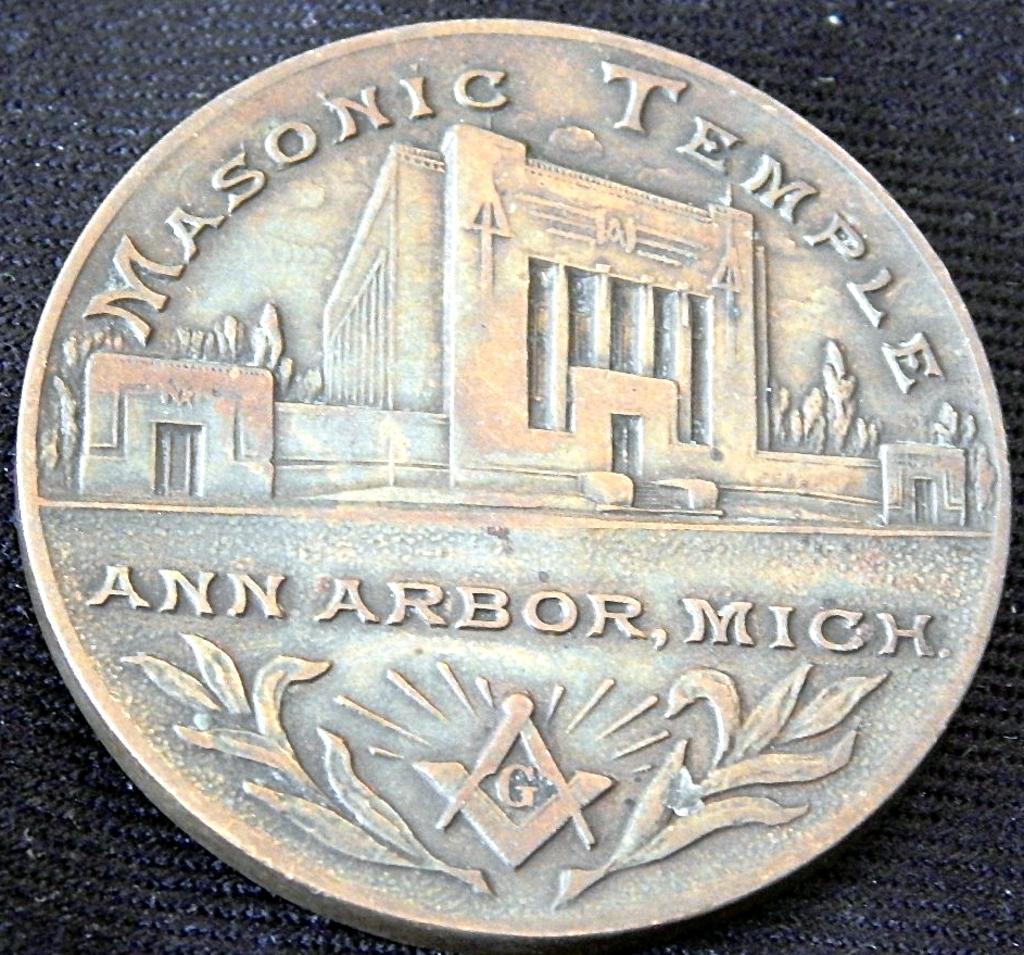What state does the coin refer to?
Make the answer very short. Michigan. What city does the coin refer to?
Your response must be concise. Ann arbor. 